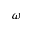Convert formula to latex. <formula><loc_0><loc_0><loc_500><loc_500>\omega</formula> 